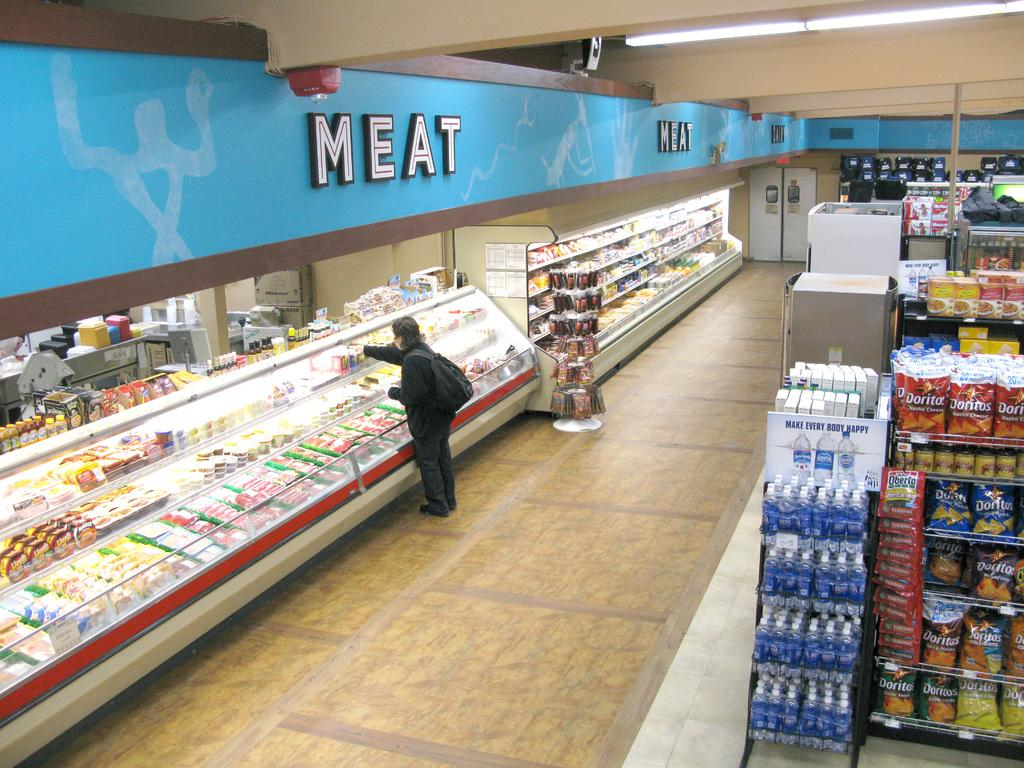<image>
Summarize the visual content of the image. A person picking out meat in a grocery store 